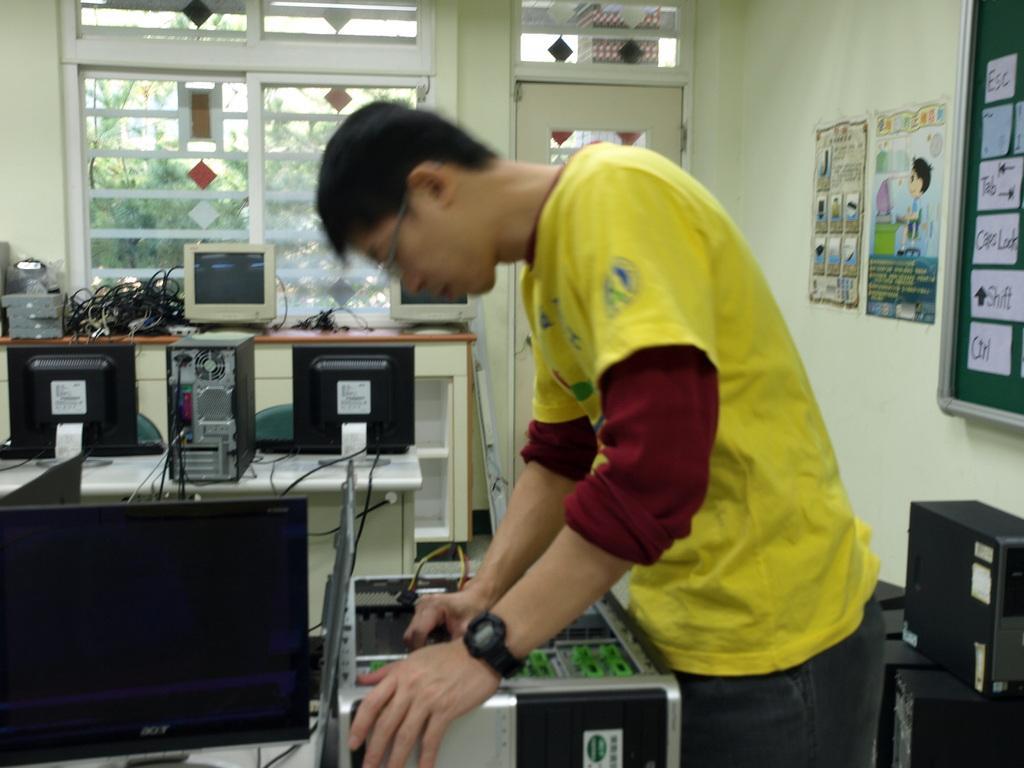Please provide a concise description of this image. In this image we can see there is a person holding an object. And there are some systems on the table. There is a door and a window. And back of the window there is a tree. There is a wall. On the wall there is a board and a poster. 